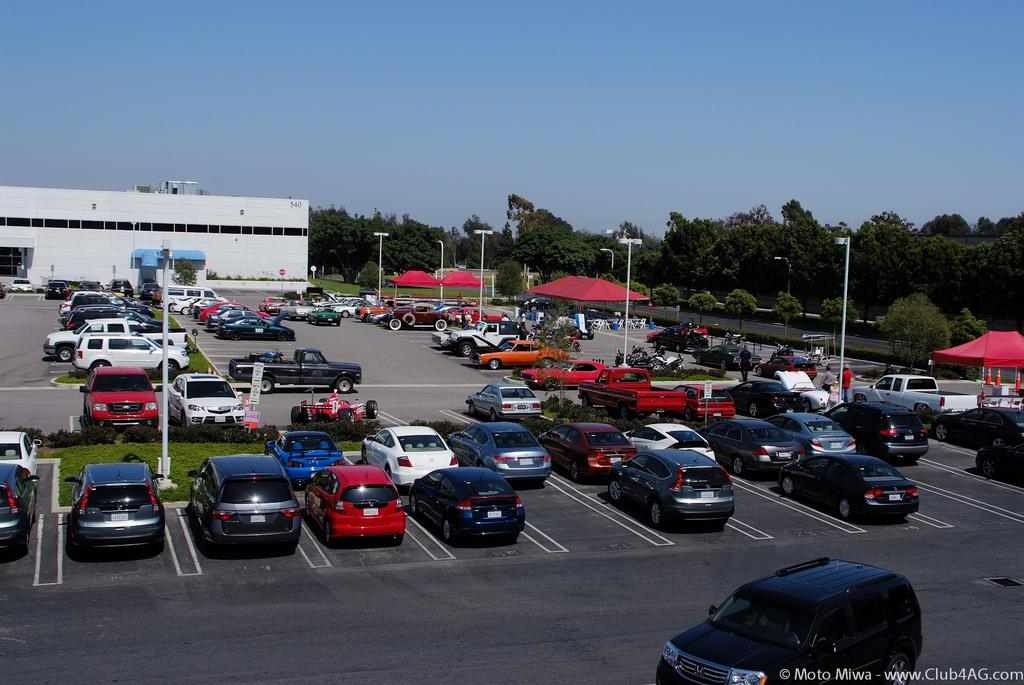What types of objects are present in the image? There are vehicles, trees, poles, signboards, traffic cones, and a shed in the image. How many vehicles are in the image, and what can be said about their colors? There are multiple vehicles in the image, and they are in different colors. What can be seen in the background of the image? There are trees in the image. Are there any structures or objects related to traffic control in the image? Yes, there are poles, signboards, and traffic cones in the image. What is the color of the sky in the image? The sky is blue in the image. What type of alarm can be heard going off in the image? There is no alarm present in the image, and therefore no such sound can be heard. Can you tell me how many bags of popcorn are visible in the image? There are no bags of popcorn present in the image. What is the material of the traffic cones in the image? The material of the traffic cones is not mentioned in the image, but they are typically made of plastic or rubber. 